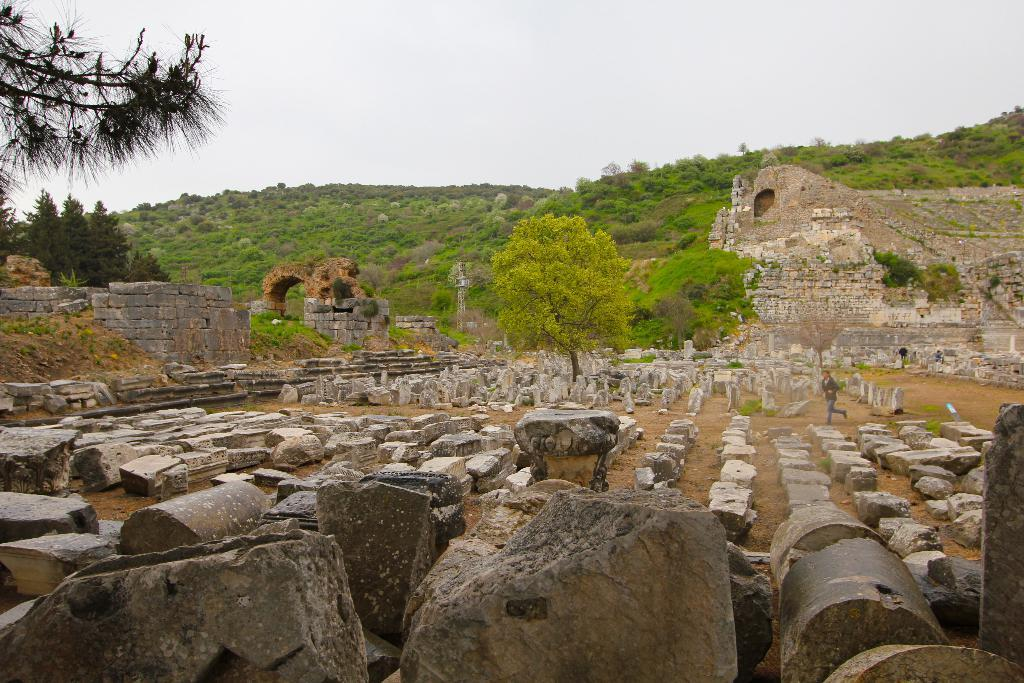What type of surface can be seen in the image? There is ground visible in the image. What is present on the ground? There are stones on the ground. Can you describe the person in the image? There is a person standing in the image. What can be seen in the distance in the image? There are trees and grass visible in the background of the image. What type of support is the person using to stand in the image? The person is standing on the ground, and there is no additional support visible in the image. Can you tell me how many loaves of bread are present in the image? There are no loaves of bread present in the image. 